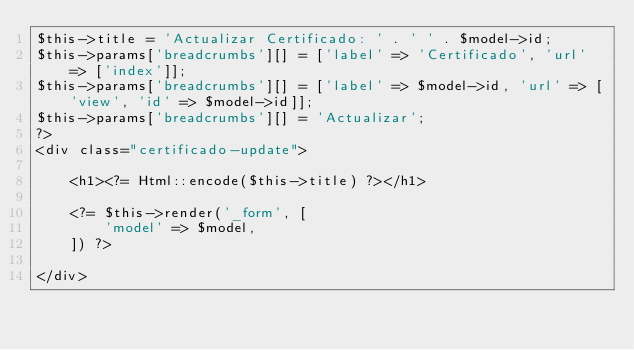<code> <loc_0><loc_0><loc_500><loc_500><_PHP_>$this->title = 'Actualizar Certificado: ' . ' ' . $model->id;
$this->params['breadcrumbs'][] = ['label' => 'Certificado', 'url' => ['index']];
$this->params['breadcrumbs'][] = ['label' => $model->id, 'url' => ['view', 'id' => $model->id]];
$this->params['breadcrumbs'][] = 'Actualizar';
?>
<div class="certificado-update">

    <h1><?= Html::encode($this->title) ?></h1>

    <?= $this->render('_form', [
        'model' => $model,
    ]) ?>

</div>
</code> 